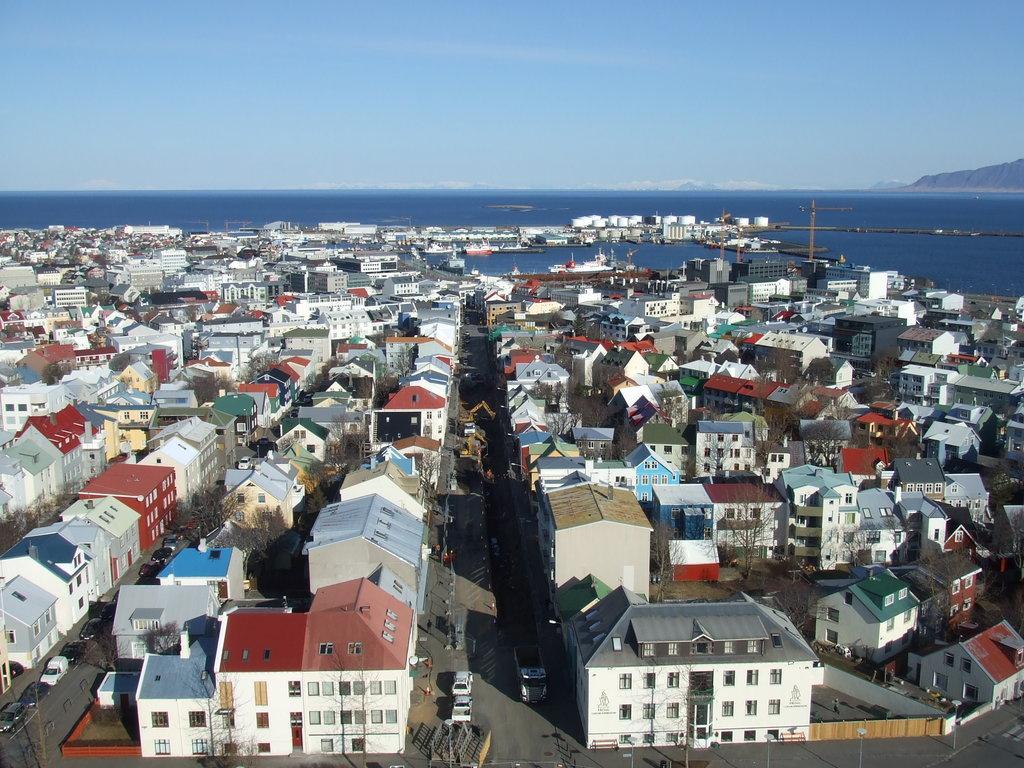Can you describe this image briefly? This is a view of a city. In this image we can see there are so many buildings, roads and some vehicles are moving on the road. In the background there is a river, mountain and sky. 